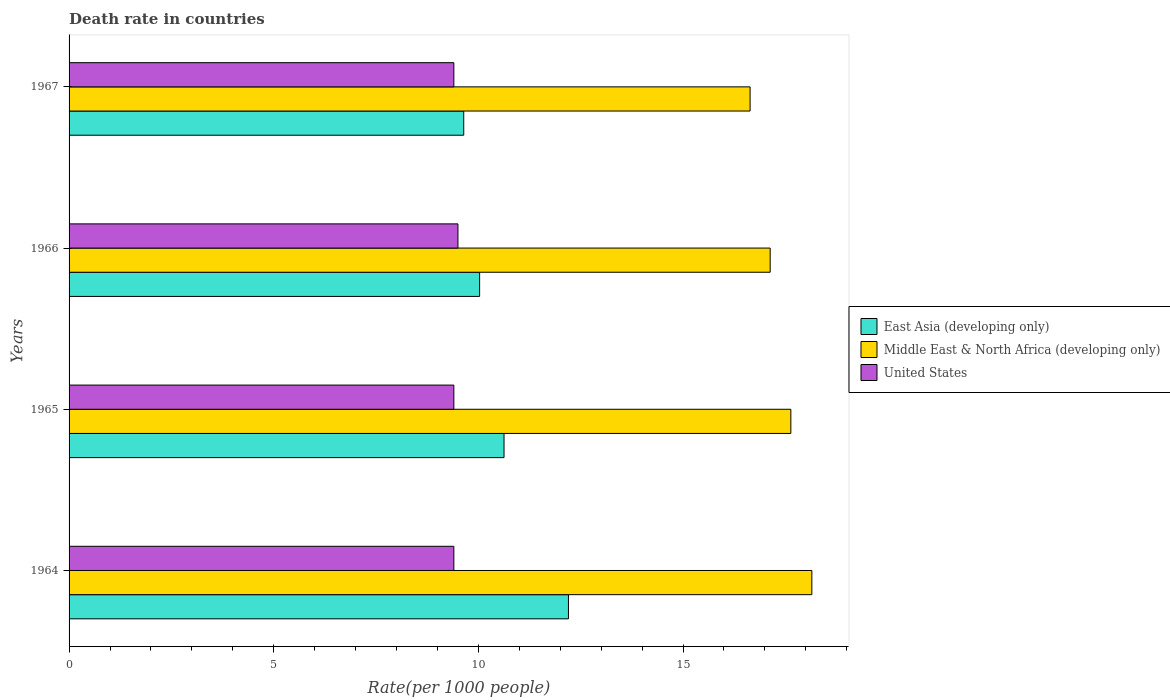How many different coloured bars are there?
Provide a succinct answer. 3. Are the number of bars on each tick of the Y-axis equal?
Offer a very short reply. Yes. What is the label of the 4th group of bars from the top?
Provide a short and direct response. 1964. In how many cases, is the number of bars for a given year not equal to the number of legend labels?
Your response must be concise. 0. What is the death rate in United States in 1967?
Provide a short and direct response. 9.4. Across all years, what is the maximum death rate in Middle East & North Africa (developing only)?
Your answer should be very brief. 18.15. In which year was the death rate in Middle East & North Africa (developing only) maximum?
Your answer should be very brief. 1964. In which year was the death rate in United States minimum?
Offer a terse response. 1964. What is the total death rate in United States in the graph?
Your response must be concise. 37.7. What is the difference between the death rate in East Asia (developing only) in 1964 and that in 1966?
Keep it short and to the point. 2.17. What is the difference between the death rate in United States in 1964 and the death rate in Middle East & North Africa (developing only) in 1965?
Give a very brief answer. -8.23. What is the average death rate in Middle East & North Africa (developing only) per year?
Make the answer very short. 17.39. In the year 1966, what is the difference between the death rate in United States and death rate in East Asia (developing only)?
Offer a very short reply. -0.53. What is the ratio of the death rate in East Asia (developing only) in 1964 to that in 1965?
Provide a succinct answer. 1.15. What is the difference between the highest and the second highest death rate in United States?
Offer a very short reply. 0.1. What is the difference between the highest and the lowest death rate in Middle East & North Africa (developing only)?
Make the answer very short. 1.51. What does the 3rd bar from the top in 1966 represents?
Your answer should be compact. East Asia (developing only). What does the 1st bar from the bottom in 1964 represents?
Provide a succinct answer. East Asia (developing only). How many bars are there?
Provide a short and direct response. 12. Are all the bars in the graph horizontal?
Provide a short and direct response. Yes. How many years are there in the graph?
Offer a very short reply. 4. Are the values on the major ticks of X-axis written in scientific E-notation?
Ensure brevity in your answer.  No. Does the graph contain grids?
Offer a very short reply. No. Where does the legend appear in the graph?
Provide a short and direct response. Center right. How many legend labels are there?
Your response must be concise. 3. How are the legend labels stacked?
Provide a short and direct response. Vertical. What is the title of the graph?
Ensure brevity in your answer.  Death rate in countries. What is the label or title of the X-axis?
Your answer should be compact. Rate(per 1000 people). What is the Rate(per 1000 people) of East Asia (developing only) in 1964?
Your answer should be compact. 12.2. What is the Rate(per 1000 people) of Middle East & North Africa (developing only) in 1964?
Your answer should be very brief. 18.15. What is the Rate(per 1000 people) of United States in 1964?
Offer a terse response. 9.4. What is the Rate(per 1000 people) in East Asia (developing only) in 1965?
Your answer should be compact. 10.63. What is the Rate(per 1000 people) in Middle East & North Africa (developing only) in 1965?
Your answer should be compact. 17.63. What is the Rate(per 1000 people) in East Asia (developing only) in 1966?
Your answer should be compact. 10.03. What is the Rate(per 1000 people) of Middle East & North Africa (developing only) in 1966?
Give a very brief answer. 17.13. What is the Rate(per 1000 people) in East Asia (developing only) in 1967?
Provide a succinct answer. 9.64. What is the Rate(per 1000 people) of Middle East & North Africa (developing only) in 1967?
Give a very brief answer. 16.64. Across all years, what is the maximum Rate(per 1000 people) in East Asia (developing only)?
Offer a terse response. 12.2. Across all years, what is the maximum Rate(per 1000 people) of Middle East & North Africa (developing only)?
Give a very brief answer. 18.15. Across all years, what is the minimum Rate(per 1000 people) in East Asia (developing only)?
Offer a terse response. 9.64. Across all years, what is the minimum Rate(per 1000 people) of Middle East & North Africa (developing only)?
Make the answer very short. 16.64. Across all years, what is the minimum Rate(per 1000 people) of United States?
Your answer should be very brief. 9.4. What is the total Rate(per 1000 people) of East Asia (developing only) in the graph?
Provide a succinct answer. 42.5. What is the total Rate(per 1000 people) in Middle East & North Africa (developing only) in the graph?
Provide a short and direct response. 69.55. What is the total Rate(per 1000 people) of United States in the graph?
Provide a short and direct response. 37.7. What is the difference between the Rate(per 1000 people) in East Asia (developing only) in 1964 and that in 1965?
Give a very brief answer. 1.57. What is the difference between the Rate(per 1000 people) of Middle East & North Africa (developing only) in 1964 and that in 1965?
Make the answer very short. 0.51. What is the difference between the Rate(per 1000 people) of United States in 1964 and that in 1965?
Provide a succinct answer. 0. What is the difference between the Rate(per 1000 people) in East Asia (developing only) in 1964 and that in 1966?
Provide a short and direct response. 2.17. What is the difference between the Rate(per 1000 people) in Middle East & North Africa (developing only) in 1964 and that in 1966?
Ensure brevity in your answer.  1.02. What is the difference between the Rate(per 1000 people) in United States in 1964 and that in 1966?
Make the answer very short. -0.1. What is the difference between the Rate(per 1000 people) of East Asia (developing only) in 1964 and that in 1967?
Your answer should be very brief. 2.56. What is the difference between the Rate(per 1000 people) in Middle East & North Africa (developing only) in 1964 and that in 1967?
Your answer should be very brief. 1.51. What is the difference between the Rate(per 1000 people) of United States in 1964 and that in 1967?
Your answer should be very brief. 0. What is the difference between the Rate(per 1000 people) of East Asia (developing only) in 1965 and that in 1966?
Keep it short and to the point. 0.6. What is the difference between the Rate(per 1000 people) of Middle East & North Africa (developing only) in 1965 and that in 1966?
Your answer should be compact. 0.51. What is the difference between the Rate(per 1000 people) in United States in 1965 and that in 1966?
Offer a very short reply. -0.1. What is the difference between the Rate(per 1000 people) in East Asia (developing only) in 1965 and that in 1967?
Ensure brevity in your answer.  0.98. What is the difference between the Rate(per 1000 people) of United States in 1965 and that in 1967?
Your response must be concise. 0. What is the difference between the Rate(per 1000 people) in East Asia (developing only) in 1966 and that in 1967?
Ensure brevity in your answer.  0.39. What is the difference between the Rate(per 1000 people) in Middle East & North Africa (developing only) in 1966 and that in 1967?
Make the answer very short. 0.49. What is the difference between the Rate(per 1000 people) in United States in 1966 and that in 1967?
Keep it short and to the point. 0.1. What is the difference between the Rate(per 1000 people) in East Asia (developing only) in 1964 and the Rate(per 1000 people) in Middle East & North Africa (developing only) in 1965?
Give a very brief answer. -5.43. What is the difference between the Rate(per 1000 people) in East Asia (developing only) in 1964 and the Rate(per 1000 people) in United States in 1965?
Ensure brevity in your answer.  2.8. What is the difference between the Rate(per 1000 people) of Middle East & North Africa (developing only) in 1964 and the Rate(per 1000 people) of United States in 1965?
Your answer should be compact. 8.75. What is the difference between the Rate(per 1000 people) in East Asia (developing only) in 1964 and the Rate(per 1000 people) in Middle East & North Africa (developing only) in 1966?
Give a very brief answer. -4.93. What is the difference between the Rate(per 1000 people) of East Asia (developing only) in 1964 and the Rate(per 1000 people) of United States in 1966?
Your response must be concise. 2.7. What is the difference between the Rate(per 1000 people) of Middle East & North Africa (developing only) in 1964 and the Rate(per 1000 people) of United States in 1966?
Your answer should be very brief. 8.65. What is the difference between the Rate(per 1000 people) of East Asia (developing only) in 1964 and the Rate(per 1000 people) of Middle East & North Africa (developing only) in 1967?
Offer a terse response. -4.44. What is the difference between the Rate(per 1000 people) in East Asia (developing only) in 1964 and the Rate(per 1000 people) in United States in 1967?
Keep it short and to the point. 2.8. What is the difference between the Rate(per 1000 people) of Middle East & North Africa (developing only) in 1964 and the Rate(per 1000 people) of United States in 1967?
Offer a very short reply. 8.75. What is the difference between the Rate(per 1000 people) in East Asia (developing only) in 1965 and the Rate(per 1000 people) in Middle East & North Africa (developing only) in 1966?
Keep it short and to the point. -6.5. What is the difference between the Rate(per 1000 people) in East Asia (developing only) in 1965 and the Rate(per 1000 people) in United States in 1966?
Offer a very short reply. 1.13. What is the difference between the Rate(per 1000 people) in Middle East & North Africa (developing only) in 1965 and the Rate(per 1000 people) in United States in 1966?
Make the answer very short. 8.13. What is the difference between the Rate(per 1000 people) in East Asia (developing only) in 1965 and the Rate(per 1000 people) in Middle East & North Africa (developing only) in 1967?
Make the answer very short. -6.01. What is the difference between the Rate(per 1000 people) in East Asia (developing only) in 1965 and the Rate(per 1000 people) in United States in 1967?
Your response must be concise. 1.23. What is the difference between the Rate(per 1000 people) in Middle East & North Africa (developing only) in 1965 and the Rate(per 1000 people) in United States in 1967?
Offer a terse response. 8.23. What is the difference between the Rate(per 1000 people) in East Asia (developing only) in 1966 and the Rate(per 1000 people) in Middle East & North Africa (developing only) in 1967?
Keep it short and to the point. -6.61. What is the difference between the Rate(per 1000 people) of East Asia (developing only) in 1966 and the Rate(per 1000 people) of United States in 1967?
Offer a terse response. 0.63. What is the difference between the Rate(per 1000 people) of Middle East & North Africa (developing only) in 1966 and the Rate(per 1000 people) of United States in 1967?
Ensure brevity in your answer.  7.73. What is the average Rate(per 1000 people) of East Asia (developing only) per year?
Provide a succinct answer. 10.62. What is the average Rate(per 1000 people) of Middle East & North Africa (developing only) per year?
Your answer should be compact. 17.39. What is the average Rate(per 1000 people) of United States per year?
Keep it short and to the point. 9.43. In the year 1964, what is the difference between the Rate(per 1000 people) of East Asia (developing only) and Rate(per 1000 people) of Middle East & North Africa (developing only)?
Offer a very short reply. -5.95. In the year 1964, what is the difference between the Rate(per 1000 people) in East Asia (developing only) and Rate(per 1000 people) in United States?
Ensure brevity in your answer.  2.8. In the year 1964, what is the difference between the Rate(per 1000 people) in Middle East & North Africa (developing only) and Rate(per 1000 people) in United States?
Your response must be concise. 8.75. In the year 1965, what is the difference between the Rate(per 1000 people) in East Asia (developing only) and Rate(per 1000 people) in Middle East & North Africa (developing only)?
Keep it short and to the point. -7.01. In the year 1965, what is the difference between the Rate(per 1000 people) of East Asia (developing only) and Rate(per 1000 people) of United States?
Keep it short and to the point. 1.23. In the year 1965, what is the difference between the Rate(per 1000 people) in Middle East & North Africa (developing only) and Rate(per 1000 people) in United States?
Your answer should be compact. 8.23. In the year 1966, what is the difference between the Rate(per 1000 people) in East Asia (developing only) and Rate(per 1000 people) in Middle East & North Africa (developing only)?
Keep it short and to the point. -7.1. In the year 1966, what is the difference between the Rate(per 1000 people) in East Asia (developing only) and Rate(per 1000 people) in United States?
Offer a terse response. 0.53. In the year 1966, what is the difference between the Rate(per 1000 people) of Middle East & North Africa (developing only) and Rate(per 1000 people) of United States?
Make the answer very short. 7.63. In the year 1967, what is the difference between the Rate(per 1000 people) of East Asia (developing only) and Rate(per 1000 people) of Middle East & North Africa (developing only)?
Make the answer very short. -7. In the year 1967, what is the difference between the Rate(per 1000 people) of East Asia (developing only) and Rate(per 1000 people) of United States?
Ensure brevity in your answer.  0.24. In the year 1967, what is the difference between the Rate(per 1000 people) of Middle East & North Africa (developing only) and Rate(per 1000 people) of United States?
Your answer should be compact. 7.24. What is the ratio of the Rate(per 1000 people) in East Asia (developing only) in 1964 to that in 1965?
Your answer should be very brief. 1.15. What is the ratio of the Rate(per 1000 people) of Middle East & North Africa (developing only) in 1964 to that in 1965?
Provide a succinct answer. 1.03. What is the ratio of the Rate(per 1000 people) of East Asia (developing only) in 1964 to that in 1966?
Your response must be concise. 1.22. What is the ratio of the Rate(per 1000 people) of Middle East & North Africa (developing only) in 1964 to that in 1966?
Make the answer very short. 1.06. What is the ratio of the Rate(per 1000 people) in United States in 1964 to that in 1966?
Offer a terse response. 0.99. What is the ratio of the Rate(per 1000 people) in East Asia (developing only) in 1964 to that in 1967?
Your answer should be compact. 1.27. What is the ratio of the Rate(per 1000 people) in Middle East & North Africa (developing only) in 1964 to that in 1967?
Keep it short and to the point. 1.09. What is the ratio of the Rate(per 1000 people) of United States in 1964 to that in 1967?
Provide a succinct answer. 1. What is the ratio of the Rate(per 1000 people) in East Asia (developing only) in 1965 to that in 1966?
Provide a short and direct response. 1.06. What is the ratio of the Rate(per 1000 people) in Middle East & North Africa (developing only) in 1965 to that in 1966?
Ensure brevity in your answer.  1.03. What is the ratio of the Rate(per 1000 people) in United States in 1965 to that in 1966?
Offer a terse response. 0.99. What is the ratio of the Rate(per 1000 people) in East Asia (developing only) in 1965 to that in 1967?
Give a very brief answer. 1.1. What is the ratio of the Rate(per 1000 people) of Middle East & North Africa (developing only) in 1965 to that in 1967?
Provide a short and direct response. 1.06. What is the ratio of the Rate(per 1000 people) in United States in 1965 to that in 1967?
Your answer should be very brief. 1. What is the ratio of the Rate(per 1000 people) of East Asia (developing only) in 1966 to that in 1967?
Keep it short and to the point. 1.04. What is the ratio of the Rate(per 1000 people) of Middle East & North Africa (developing only) in 1966 to that in 1967?
Ensure brevity in your answer.  1.03. What is the ratio of the Rate(per 1000 people) in United States in 1966 to that in 1967?
Offer a very short reply. 1.01. What is the difference between the highest and the second highest Rate(per 1000 people) of East Asia (developing only)?
Provide a short and direct response. 1.57. What is the difference between the highest and the second highest Rate(per 1000 people) of Middle East & North Africa (developing only)?
Provide a succinct answer. 0.51. What is the difference between the highest and the lowest Rate(per 1000 people) of East Asia (developing only)?
Make the answer very short. 2.56. What is the difference between the highest and the lowest Rate(per 1000 people) of Middle East & North Africa (developing only)?
Your answer should be very brief. 1.51. What is the difference between the highest and the lowest Rate(per 1000 people) in United States?
Offer a very short reply. 0.1. 